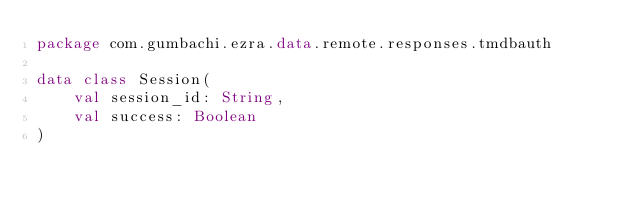Convert code to text. <code><loc_0><loc_0><loc_500><loc_500><_Kotlin_>package com.gumbachi.ezra.data.remote.responses.tmdbauth

data class Session(
    val session_id: String,
    val success: Boolean
)</code> 